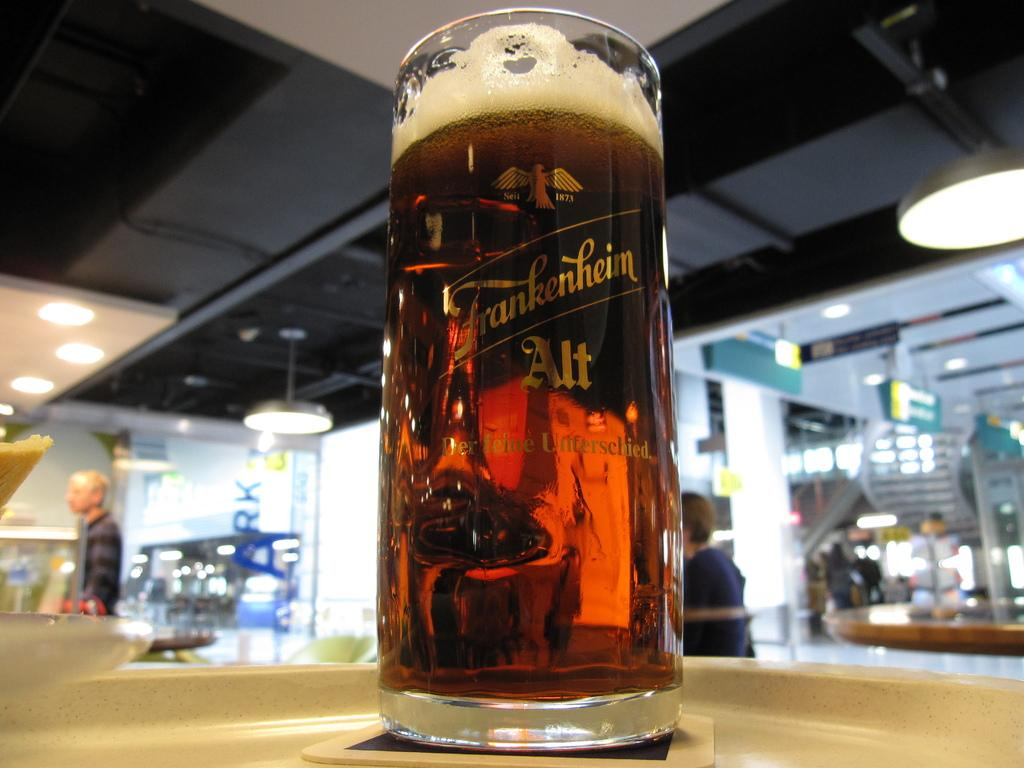Provide a one-sentence caption for the provided image. Frankenheim glass that contains beer on a table. 